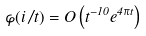Convert formula to latex. <formula><loc_0><loc_0><loc_500><loc_500>\varphi ( i / t ) = O \left ( t ^ { - 1 0 } e ^ { 4 \pi t } \right )</formula> 